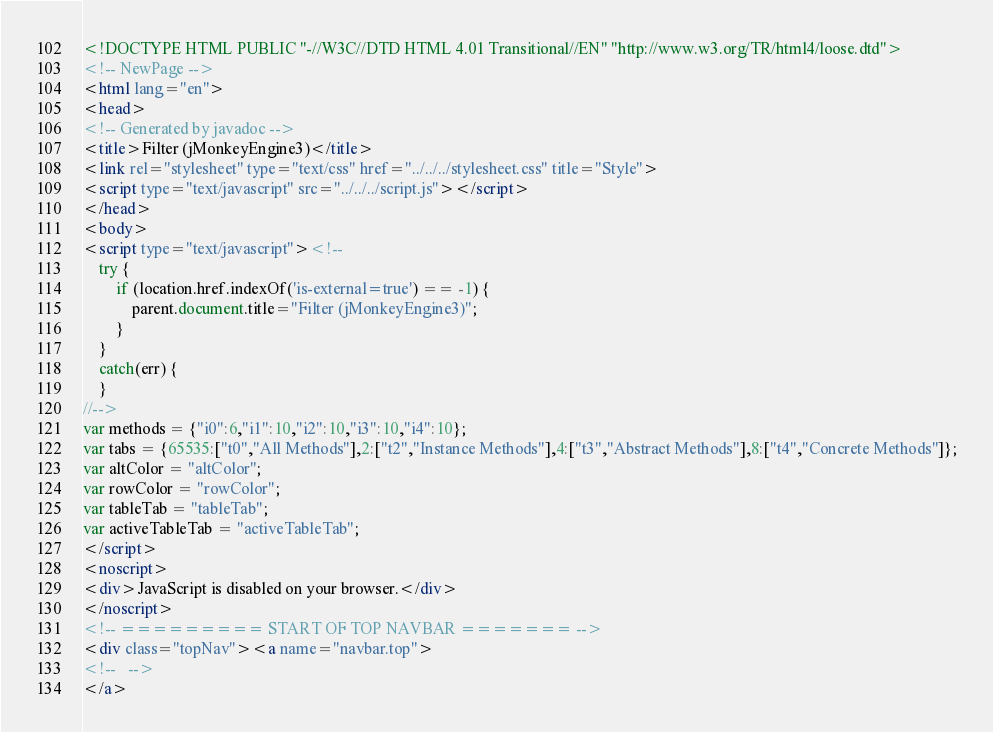Convert code to text. <code><loc_0><loc_0><loc_500><loc_500><_HTML_><!DOCTYPE HTML PUBLIC "-//W3C//DTD HTML 4.01 Transitional//EN" "http://www.w3.org/TR/html4/loose.dtd">
<!-- NewPage -->
<html lang="en">
<head>
<!-- Generated by javadoc -->
<title>Filter (jMonkeyEngine3)</title>
<link rel="stylesheet" type="text/css" href="../../../stylesheet.css" title="Style">
<script type="text/javascript" src="../../../script.js"></script>
</head>
<body>
<script type="text/javascript"><!--
    try {
        if (location.href.indexOf('is-external=true') == -1) {
            parent.document.title="Filter (jMonkeyEngine3)";
        }
    }
    catch(err) {
    }
//-->
var methods = {"i0":6,"i1":10,"i2":10,"i3":10,"i4":10};
var tabs = {65535:["t0","All Methods"],2:["t2","Instance Methods"],4:["t3","Abstract Methods"],8:["t4","Concrete Methods"]};
var altColor = "altColor";
var rowColor = "rowColor";
var tableTab = "tableTab";
var activeTableTab = "activeTableTab";
</script>
<noscript>
<div>JavaScript is disabled on your browser.</div>
</noscript>
<!-- ========= START OF TOP NAVBAR ======= -->
<div class="topNav"><a name="navbar.top">
<!--   -->
</a></code> 